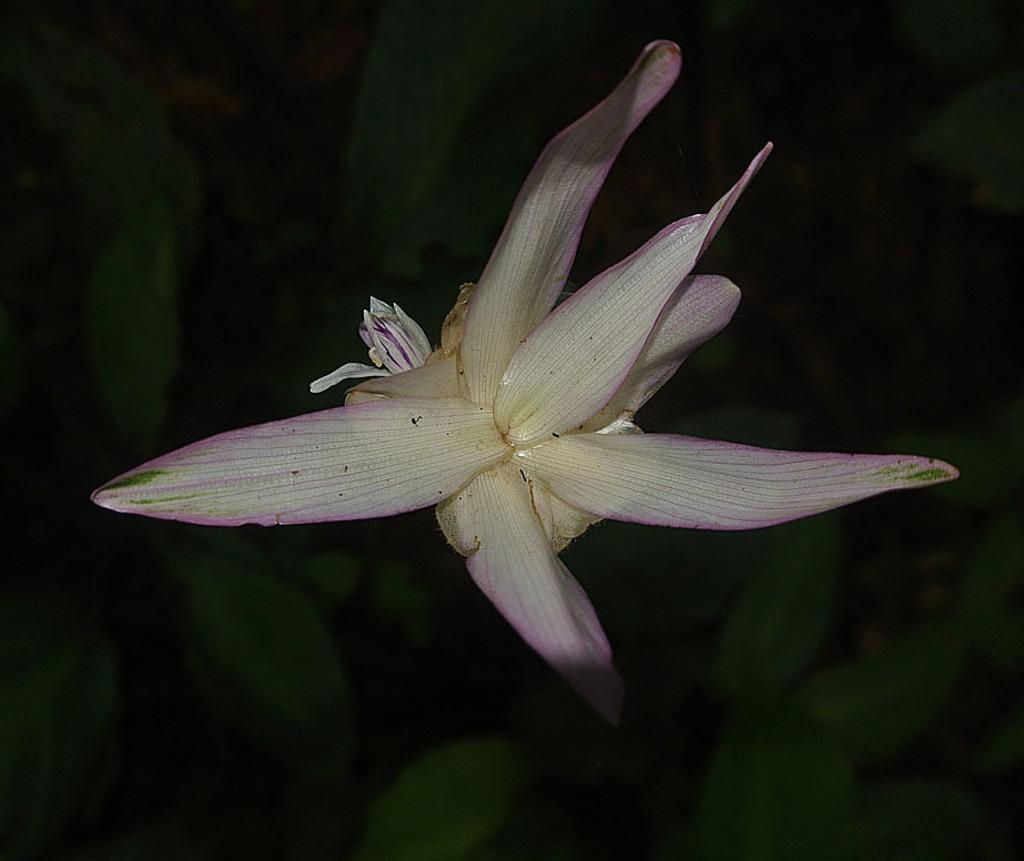Could you give a brief overview of what you see in this image? In this image we can see a flower. In the background , we can see group of plants. 